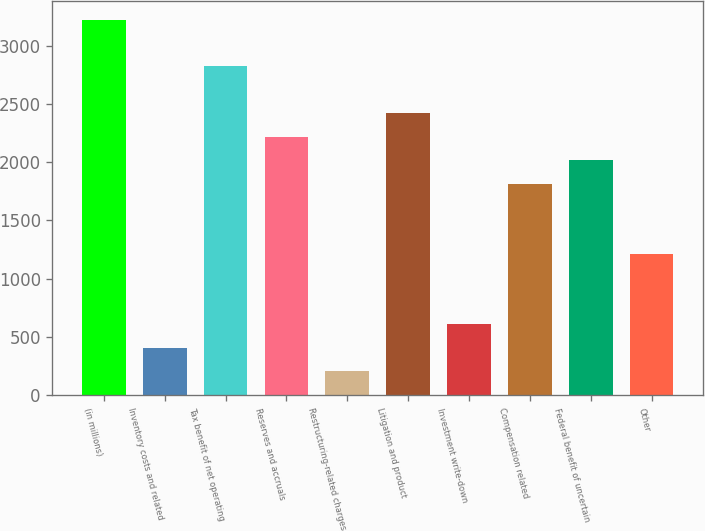Convert chart. <chart><loc_0><loc_0><loc_500><loc_500><bar_chart><fcel>(in millions)<fcel>Inventory costs and related<fcel>Tax benefit of net operating<fcel>Reserves and accruals<fcel>Restructuring-related charges<fcel>Litigation and product<fcel>Investment write-down<fcel>Compensation related<fcel>Federal benefit of uncertain<fcel>Other<nl><fcel>3224.2<fcel>407.4<fcel>2821.8<fcel>2218.2<fcel>206.2<fcel>2419.4<fcel>608.6<fcel>1815.8<fcel>2017<fcel>1212.2<nl></chart> 